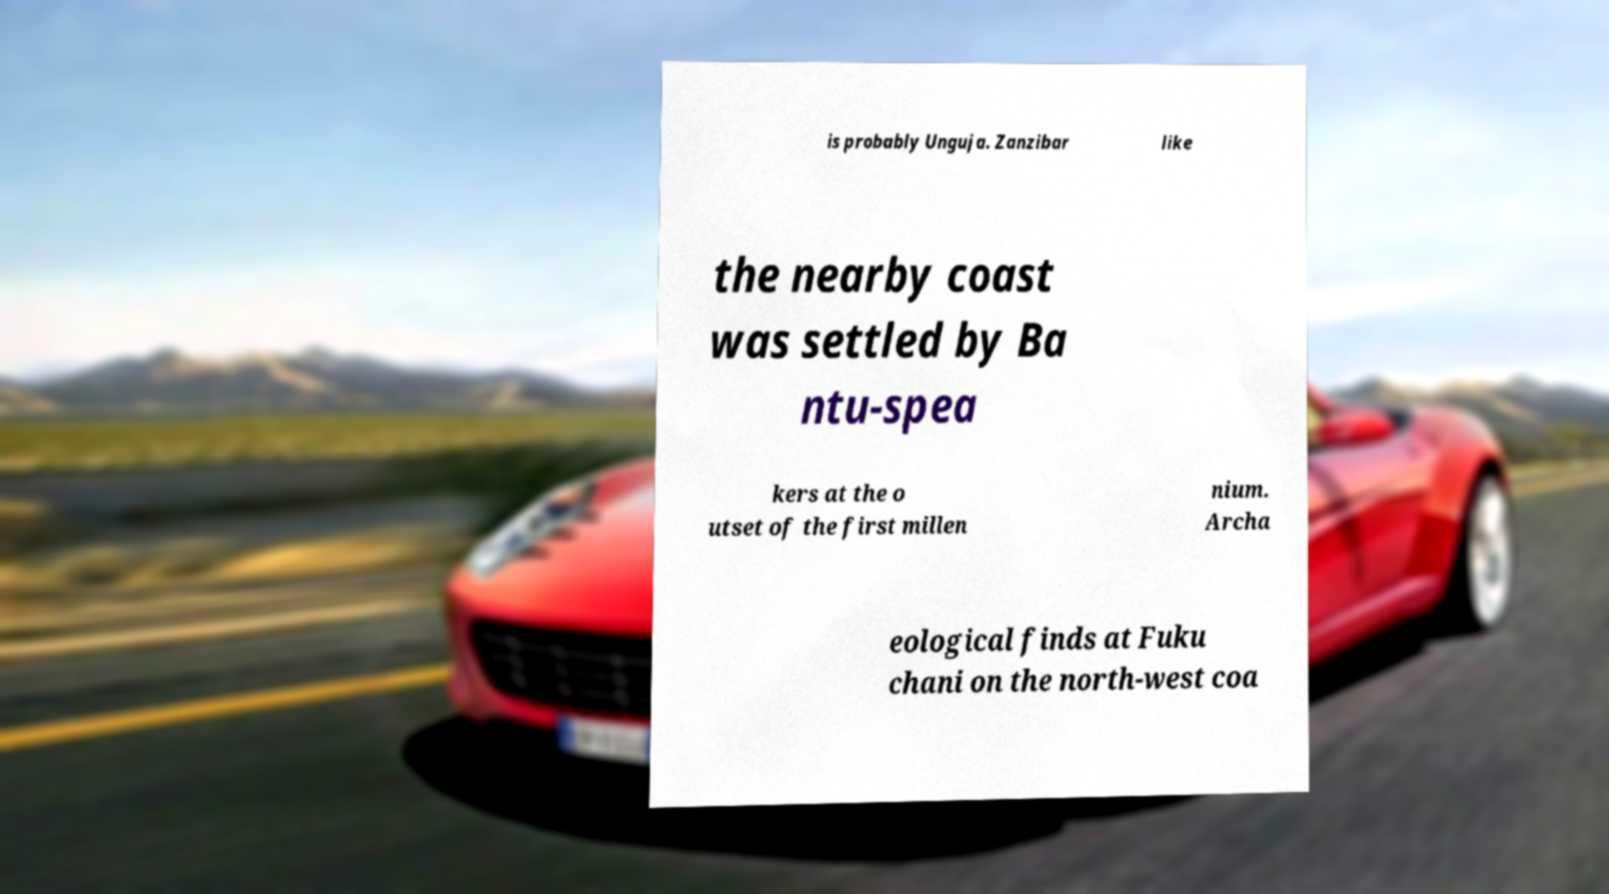Could you assist in decoding the text presented in this image and type it out clearly? is probably Unguja. Zanzibar like the nearby coast was settled by Ba ntu-spea kers at the o utset of the first millen nium. Archa eological finds at Fuku chani on the north-west coa 